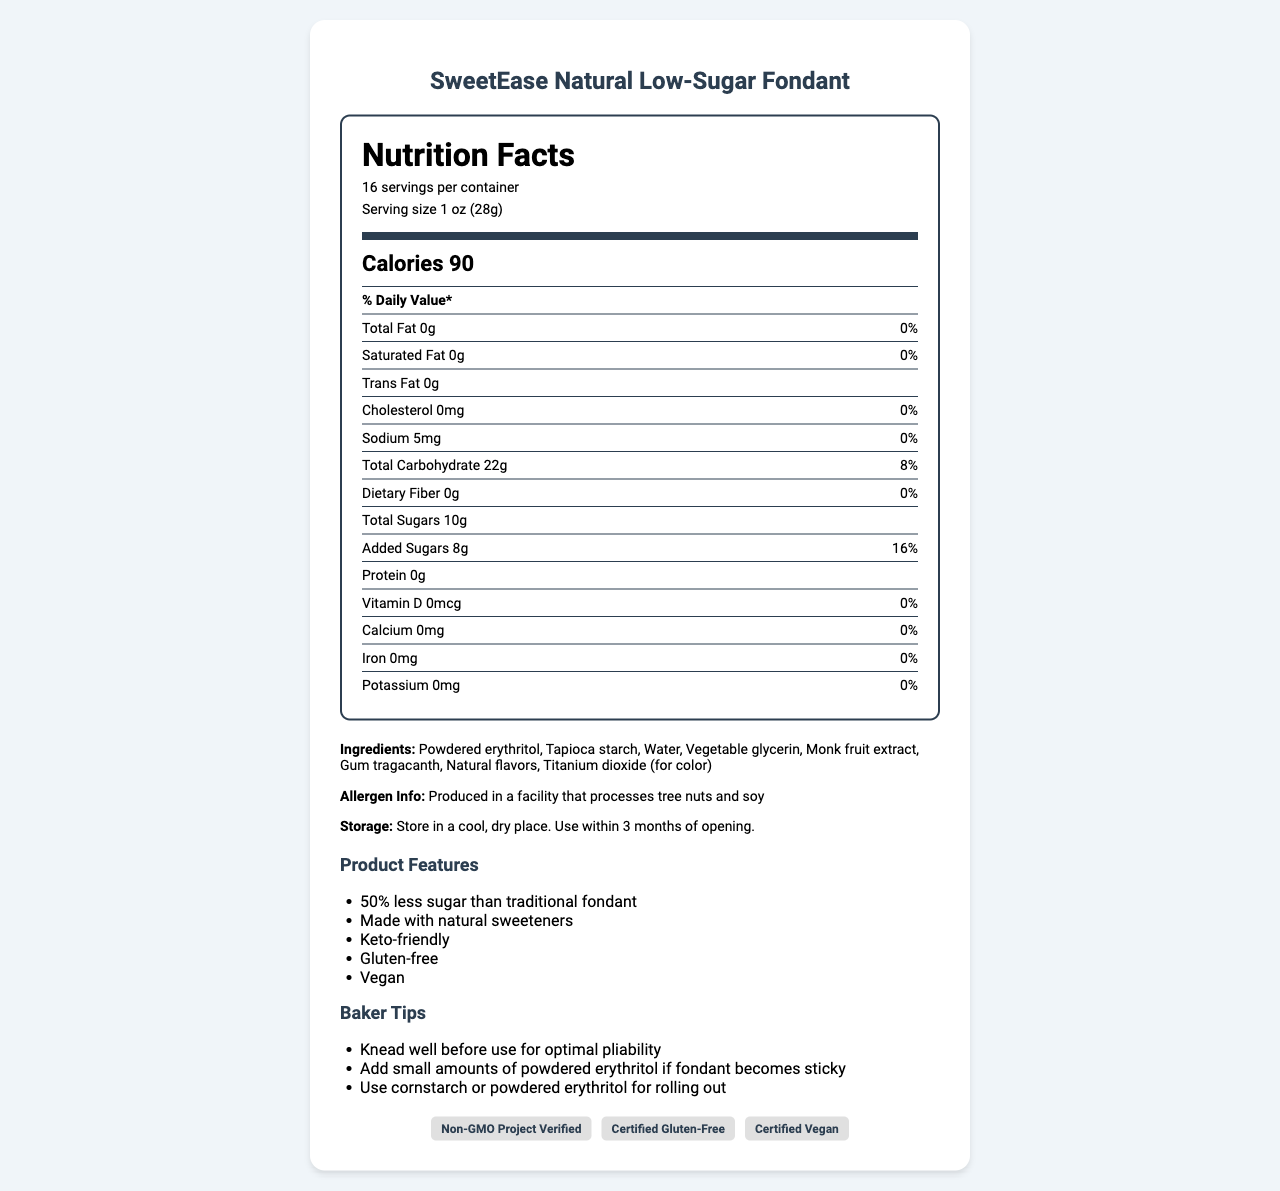What is the serving size of SweetEase Natural Low-Sugar Fondant? The serving size is explicitly stated as 1 oz (28g) in the document.
Answer: 1 oz (28g) How many calories are there per serving? The document lists the number of calories per serving as 90.
Answer: 90 calories What is the amount of total fat in one serving? The document shows that the total fat amount is 0g per serving.
Answer: 0g How much sodium is in one serving? The document displays the sodium content per serving as 5mg.
Answer: 5mg What percentage of the daily value for added sugars does one serving provide? The daily value percentage for added sugars is given as 16%.
Answer: 16% What is one of the ingredients used in SweetEase Natural Low-Sugar Fondant? Powdered erythritol is listed as one of the ingredients.
Answer: Powdered erythritol True or False: SweetEase Natural Low-Sugar Fondant contains cholesterol. The document indicates that the amount of cholesterol per serving is 0mg.
Answer: False Which of the following certifications does the SweetEase fondant have? A. USDA Organic B. Certified Gluten-Free C. Fair Trade D. Halal The SweetEase Natural Low-Sugar Fondant has the Certified Gluten-Free certification.
Answer: B Which of the following is NOT an ingredient in SweetEase Natural Low-Sugar Fondant? A. Tapioca starch B. Honey C. Vegetable glycerin D. Natural flavors Honey is not listed as an ingredient in the document.
Answer: B Does SweetEase fondant contain any dietary fiber? The document shows that the dietary fiber amount is 0g per serving.
Answer: No What is the main idea of the document? The document thoroughly describes the nutritional content, ingredients, storage instructions, and special features of the SweetEase Natural Low-Sugar Fondant, along with baker tips and its certifications.
Answer: The document provides nutritional information, ingredients, allergen info, storage instructions, product features, baker tips, and certifications for SweetEase Natural Low-Sugar Fondant. How should the fondant be stored after opening? The storage instructions advise to store it in a cool, dry place and to use it within 3 months of opening.
Answer: In a cool, dry place and used within 3 months What natural sweetener is mentioned in the ingredients list? Monk fruit extract is listed among the ingredients as a natural sweetener.
Answer: Monk fruit extract What should you do if the fondant becomes sticky during use? The baker tips suggest adding small amounts of powdered erythritol if the fondant becomes sticky.
Answer: Add small amounts of powdered erythritol Is the SweetEase Natural Low-Sugar Fondant vegan-friendly? The product features state that it is vegan.
Answer: Yes Are there any vitamins or minerals with a daily value percentage above 0% in the fondant? The document shows that Vitamin D, Calcium, Iron, and Potassium all have 0% daily value.
Answer: No Produced in a facility that processes which allergens? The allergen information states the fondant is produced in a facility that processes tree nuts and soy.
Answer: Tree nuts and soy What is the shelf life of SweetEase Natural Low-Sugar Fondant after opening? The storage instructions mention that the fondant should be used within 3 months after opening.
Answer: 3 months What are the certifications logos mentioned? The document contains logos for Non-GMO Project Verified, Certified Gluten-Free, and Certified Vegan certifications.
Answer: Non-GMO Project Verified, Certified Gluten-Free, Certified Vegan How many grams of total carbohydrate does the fondant have per serving? The document specifies that the total carbohydrate content per serving is 22g.
Answer: 22g What is the source of the vegetable glycerin used in SweetEase Natural Low-Sugar Fondant? The source of vegetable glycerin is not provided in the document; hence, it cannot be determined.
Answer: Cannot be determined 